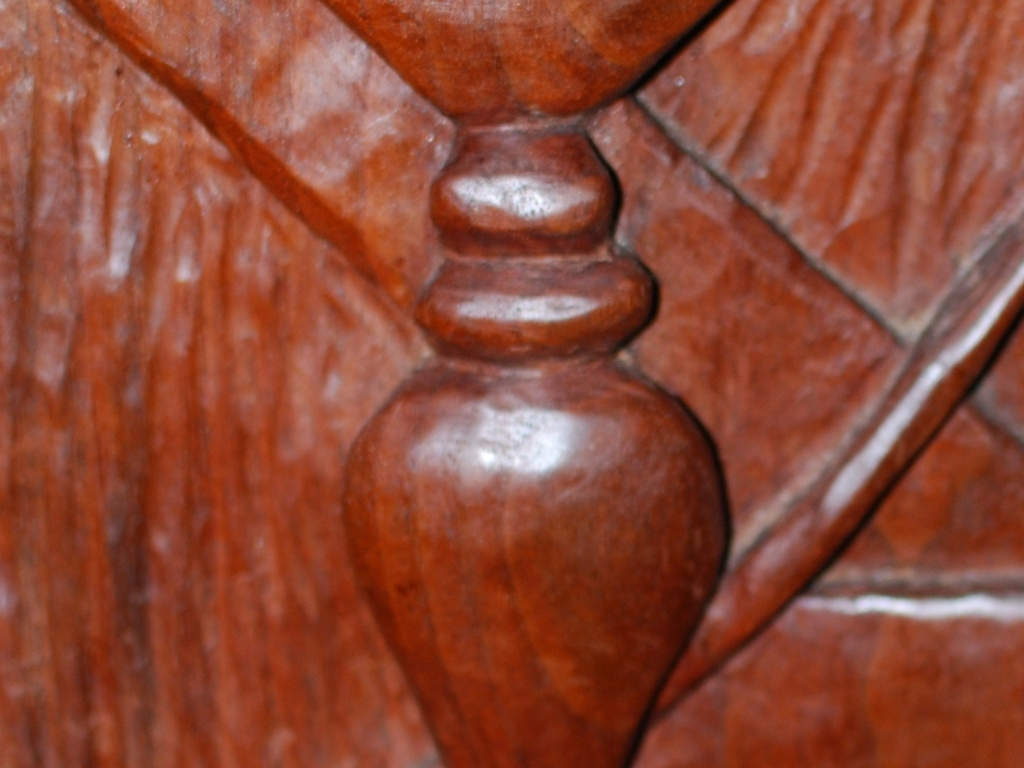Can you tell what this object is made of? Based on the texture and color, it appears to be carved from wood, likely a part of a piece of furniture or a wooden sculpture. 